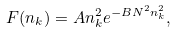Convert formula to latex. <formula><loc_0><loc_0><loc_500><loc_500>F ( n _ { k } ) = A n _ { k } ^ { 2 } e ^ { - B N ^ { 2 } n _ { k } ^ { 2 } } ,</formula> 